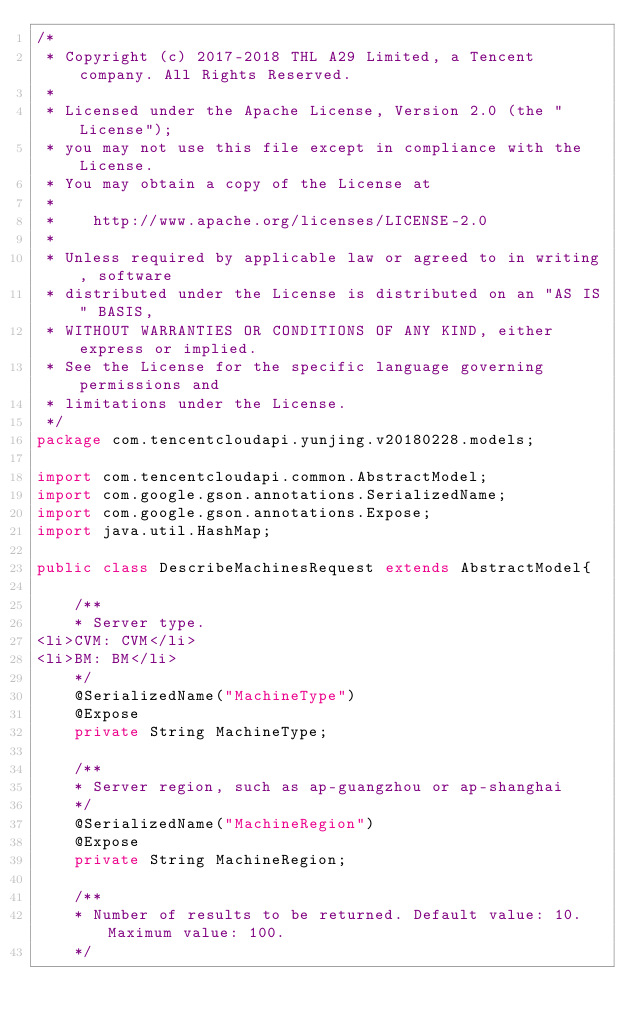<code> <loc_0><loc_0><loc_500><loc_500><_Java_>/*
 * Copyright (c) 2017-2018 THL A29 Limited, a Tencent company. All Rights Reserved.
 *
 * Licensed under the Apache License, Version 2.0 (the "License");
 * you may not use this file except in compliance with the License.
 * You may obtain a copy of the License at
 *
 *    http://www.apache.org/licenses/LICENSE-2.0
 *
 * Unless required by applicable law or agreed to in writing, software
 * distributed under the License is distributed on an "AS IS" BASIS,
 * WITHOUT WARRANTIES OR CONDITIONS OF ANY KIND, either express or implied.
 * See the License for the specific language governing permissions and
 * limitations under the License.
 */
package com.tencentcloudapi.yunjing.v20180228.models;

import com.tencentcloudapi.common.AbstractModel;
import com.google.gson.annotations.SerializedName;
import com.google.gson.annotations.Expose;
import java.util.HashMap;

public class DescribeMachinesRequest extends AbstractModel{

    /**
    * Server type.
<li>CVM: CVM</li>
<li>BM: BM</li>
    */
    @SerializedName("MachineType")
    @Expose
    private String MachineType;

    /**
    * Server region, such as ap-guangzhou or ap-shanghai
    */
    @SerializedName("MachineRegion")
    @Expose
    private String MachineRegion;

    /**
    * Number of results to be returned. Default value: 10. Maximum value: 100.
    */</code> 